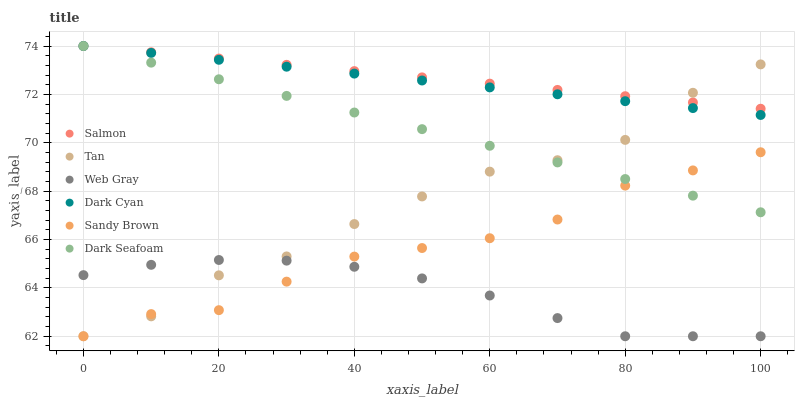Does Web Gray have the minimum area under the curve?
Answer yes or no. Yes. Does Salmon have the maximum area under the curve?
Answer yes or no. Yes. Does Dark Seafoam have the minimum area under the curve?
Answer yes or no. No. Does Dark Seafoam have the maximum area under the curve?
Answer yes or no. No. Is Dark Seafoam the smoothest?
Answer yes or no. Yes. Is Tan the roughest?
Answer yes or no. Yes. Is Salmon the smoothest?
Answer yes or no. No. Is Salmon the roughest?
Answer yes or no. No. Does Web Gray have the lowest value?
Answer yes or no. Yes. Does Dark Seafoam have the lowest value?
Answer yes or no. No. Does Dark Cyan have the highest value?
Answer yes or no. Yes. Does Tan have the highest value?
Answer yes or no. No. Is Sandy Brown less than Salmon?
Answer yes or no. Yes. Is Dark Cyan greater than Web Gray?
Answer yes or no. Yes. Does Dark Cyan intersect Salmon?
Answer yes or no. Yes. Is Dark Cyan less than Salmon?
Answer yes or no. No. Is Dark Cyan greater than Salmon?
Answer yes or no. No. Does Sandy Brown intersect Salmon?
Answer yes or no. No. 